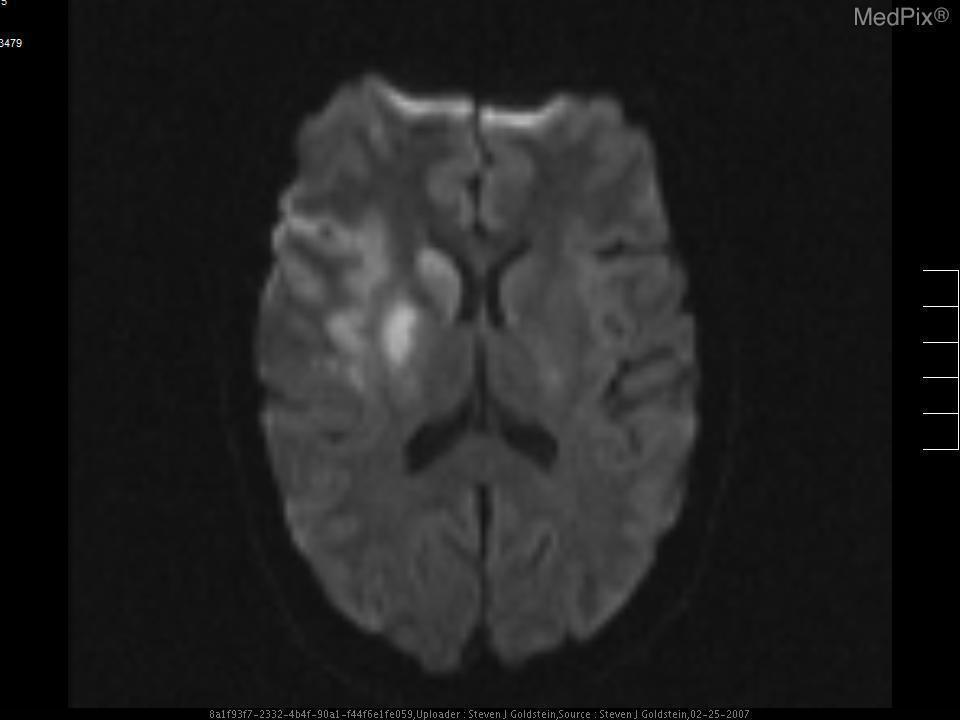What region of the brain shows hyperintensity?
Concise answer only. Right lenticular nucleus. What type of mri sequence is this?
Short answer required. Diffusion weighted imaging (dwi). On which side of the brain is the infarction?
Answer briefly. Right side. 